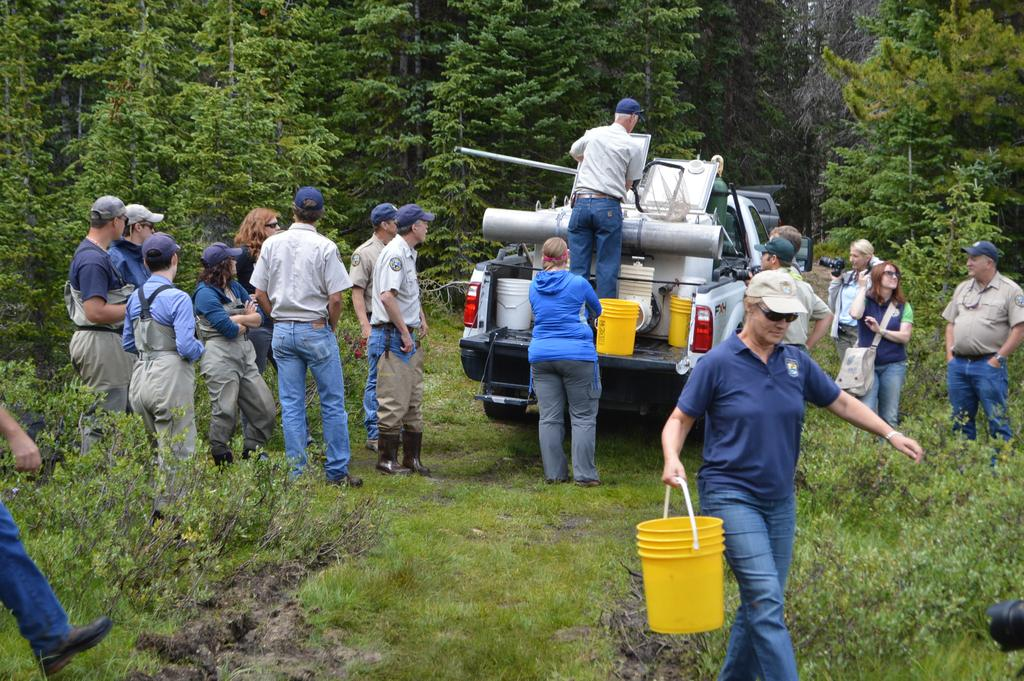What is the person in the image holding? The person is standing and holding a basket in the image. Can you describe the group of people in the image? There is a group of people standing in the image. What can be seen on the vehicle in the image? There are buckets on a vehicle in the image. What is visible in the background of the image? There are trees in the background of the image. What type of offer is the person making to the cows in the image? There are no cows present in the image, so it is not possible to determine if the person is making any offer to them. 